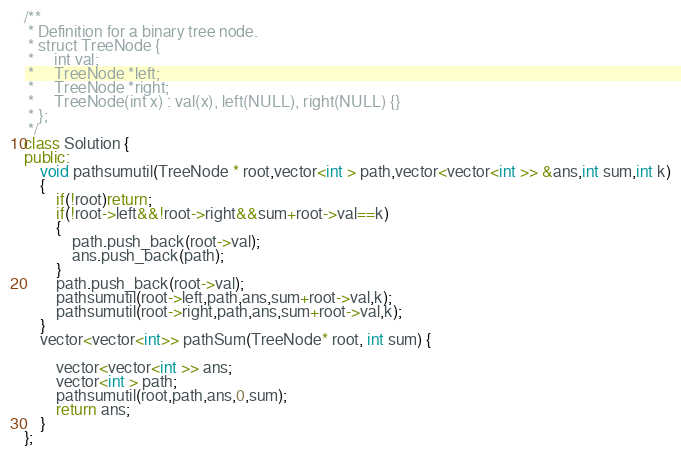Convert code to text. <code><loc_0><loc_0><loc_500><loc_500><_C++_>/**
 * Definition for a binary tree node.
 * struct TreeNode {
 *     int val;
 *     TreeNode *left;
 *     TreeNode *right;
 *     TreeNode(int x) : val(x), left(NULL), right(NULL) {}
 * };
 */
class Solution {
public:
    void pathsumutil(TreeNode * root,vector<int > path,vector<vector<int >> &ans,int sum,int k)
    {
        if(!root)return;
        if(!root->left&&!root->right&&sum+root->val==k)
        {
            path.push_back(root->val);
            ans.push_back(path);
        }
        path.push_back(root->val);
        pathsumutil(root->left,path,ans,sum+root->val,k);
        pathsumutil(root->right,path,ans,sum+root->val,k);
    }
    vector<vector<int>> pathSum(TreeNode* root, int sum) {
        
        vector<vector<int >> ans;
        vector<int > path;
        pathsumutil(root,path,ans,0,sum);
        return ans;
    }
};
</code> 